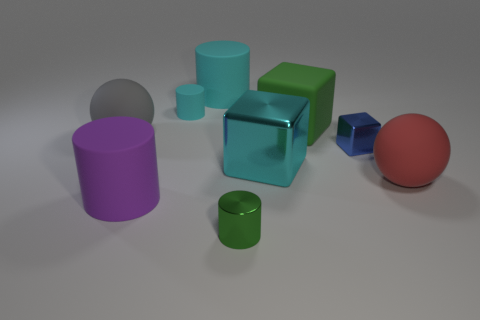Subtract 1 cylinders. How many cylinders are left? 3 Subtract all brown cylinders. Subtract all blue spheres. How many cylinders are left? 4 Add 1 big cyan rubber things. How many objects exist? 10 Subtract all cylinders. How many objects are left? 5 Subtract 0 yellow balls. How many objects are left? 9 Subtract all cyan cylinders. Subtract all tiny gray rubber things. How many objects are left? 7 Add 3 large red balls. How many large red balls are left? 4 Add 4 tiny brown blocks. How many tiny brown blocks exist? 4 